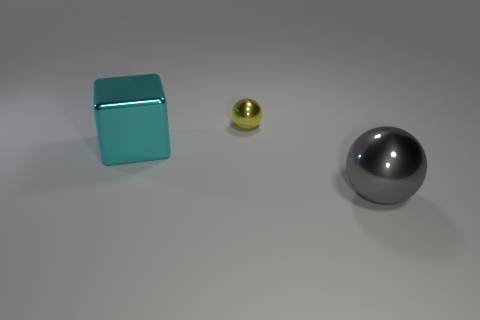Is there any other thing that has the same size as the yellow metal object?
Keep it short and to the point. No. Are there more shiny things that are in front of the large cyan shiny thing than big purple shiny blocks?
Keep it short and to the point. Yes. What material is the ball that is the same size as the cyan block?
Provide a short and direct response. Metal. Is there a ball that has the same size as the metal block?
Provide a succinct answer. Yes. There is a block in front of the yellow metal sphere; what size is it?
Your answer should be very brief. Large. How big is the yellow object?
Provide a short and direct response. Small. What number of balls are tiny brown things or small yellow objects?
Provide a succinct answer. 1. The yellow object that is made of the same material as the big block is what size?
Provide a short and direct response. Small. What number of small shiny spheres have the same color as the big cube?
Your answer should be compact. 0. Are there any cyan metal blocks in front of the large cyan object?
Keep it short and to the point. No. 